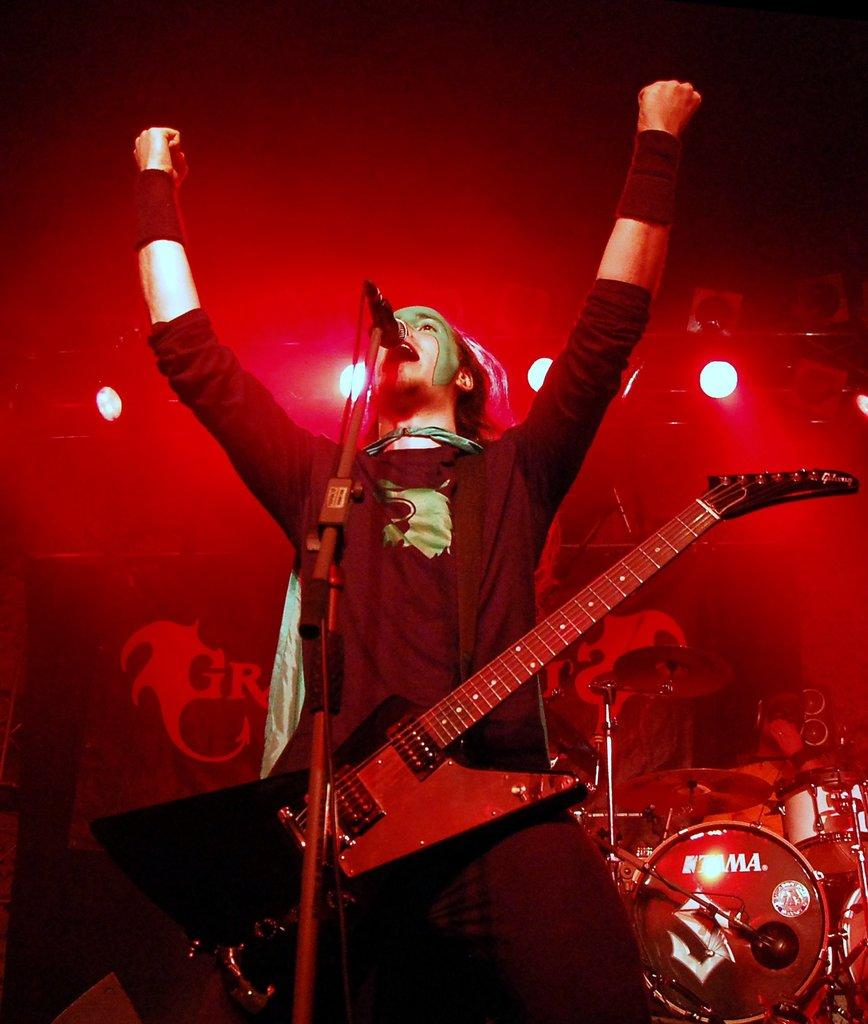What is the main subject of the image? There is a man in the image. What is the man doing in the image? The man is standing in the image. What object is the man carrying? The man is carrying a guitar. What is in front of the man? There is a microphone in front of the man. What can be seen in the background of the image? There is a drum set and lights visible in the background of the image. What type of toy is the man playing with in the image? There is no toy present in the image; the man is carrying a guitar and standing near a microphone. What kind of loaf is the man holding in the image? There is no loaf present in the image; the man is carrying a guitar and standing near a microphone. 